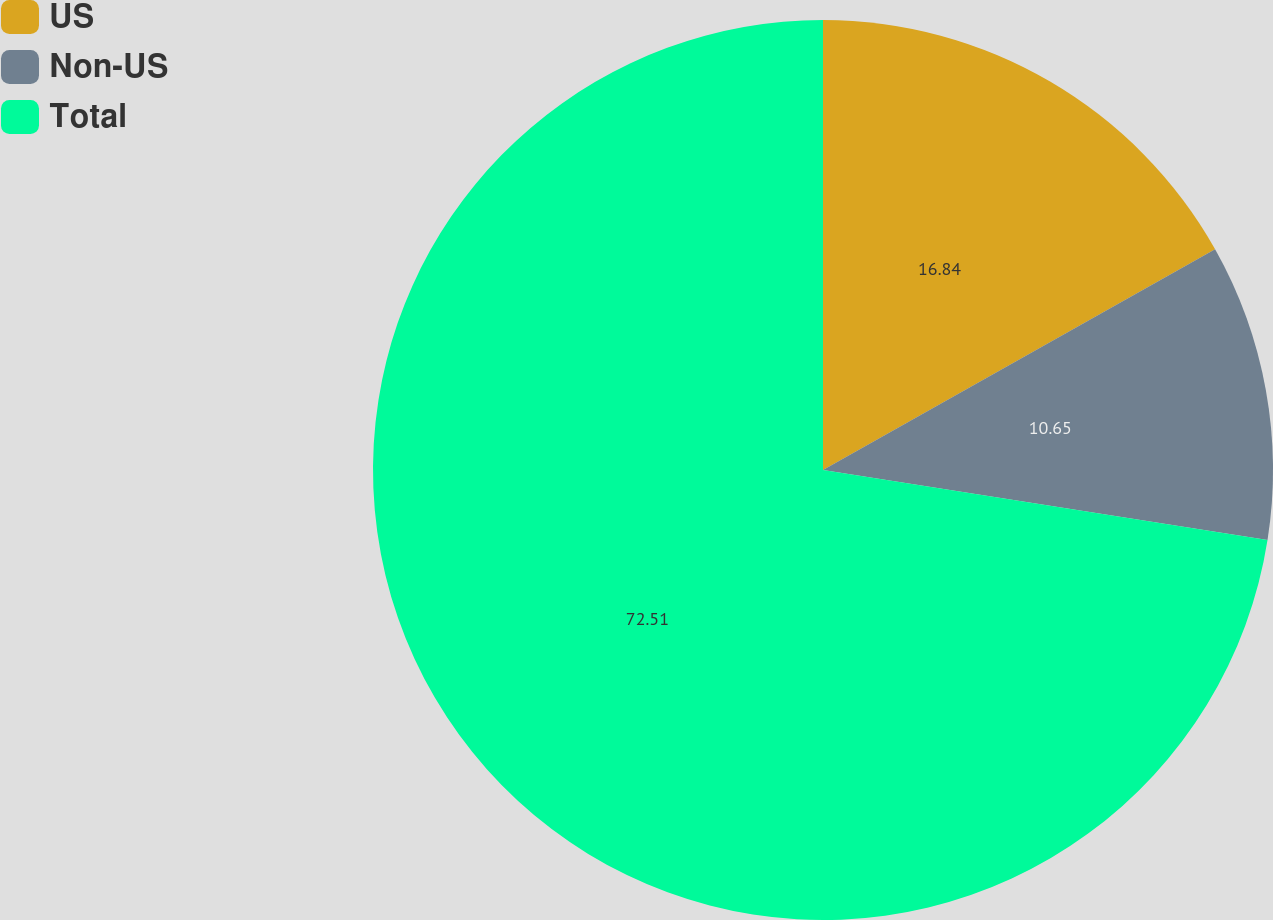<chart> <loc_0><loc_0><loc_500><loc_500><pie_chart><fcel>US<fcel>Non-US<fcel>Total<nl><fcel>16.84%<fcel>10.65%<fcel>72.52%<nl></chart> 